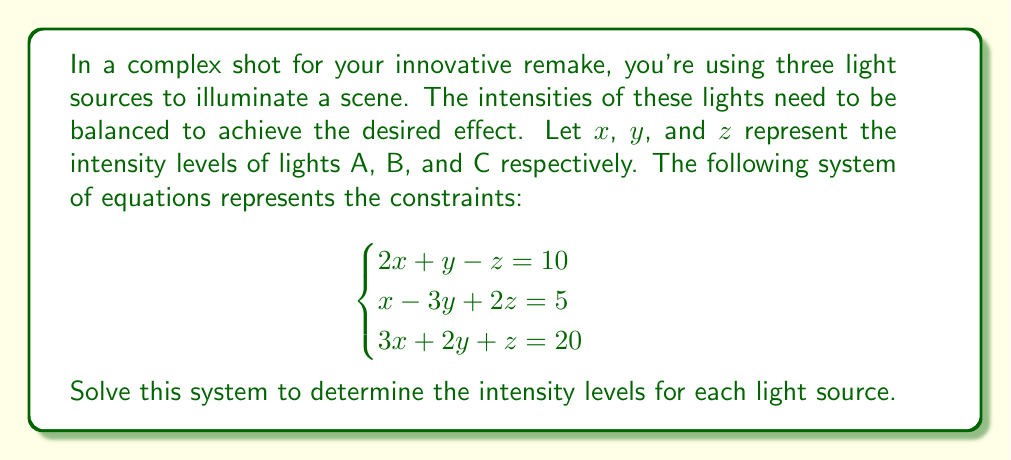Provide a solution to this math problem. Let's solve this system of equations using Gaussian elimination:

1) First, write the augmented matrix:

   $$\begin{bmatrix}
   2 & 1 & -1 & 10 \\
   1 & -3 & 2 & 5 \\
   3 & 2 & 1 & 20
   \end{bmatrix}$$

2) Multiply the first row by -1/2 and add it to the second row:

   $$\begin{bmatrix}
   2 & 1 & -1 & 10 \\
   0 & -3.5 & 2.5 & 0 \\
   3 & 2 & 1 & 20
   \end{bmatrix}$$

3) Multiply the first row by -3/2 and add it to the third row:

   $$\begin{bmatrix}
   2 & 1 & -1 & 10 \\
   0 & -3.5 & 2.5 & 0 \\
   0 & 0.5 & 2.5 & 5
   \end{bmatrix}$$

4) Multiply the second row by -1/7 to simplify:

   $$\begin{bmatrix}
   2 & 1 & -1 & 10 \\
   0 & 1 & -\frac{5}{7} & 0 \\
   0 & 0.5 & 2.5 & 5
   \end{bmatrix}$$

5) Multiply the second row by -0.5 and add it to the third row:

   $$\begin{bmatrix}
   2 & 1 & -1 & 10 \\
   0 & 1 & -\frac{5}{7} & 0 \\
   0 & 0 & \frac{20}{7} & 5
   \end{bmatrix}$$

6) Now we have an upper triangular matrix. Solve for z:

   $\frac{20}{7}z = 5$
   $z = \frac{7}{4}$

7) Substitute z into the second equation:

   $y - \frac{5}{7}(\frac{7}{4}) = 0$
   $y - \frac{5}{4} = 0$
   $y = \frac{5}{4}$

8) Substitute y and z into the first equation:

   $2x + \frac{5}{4} - \frac{7}{4} = 10$
   $2x = 11$
   $x = \frac{11}{2}$

Therefore, the solution is $x = \frac{11}{2}$, $y = \frac{5}{4}$, and $z = \frac{7}{4}$.
Answer: $x = \frac{11}{2}$, $y = \frac{5}{4}$, $z = \frac{7}{4}$ 